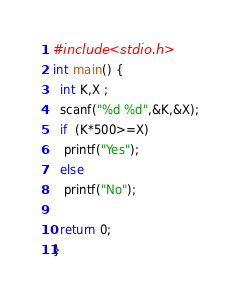<code> <loc_0><loc_0><loc_500><loc_500><_C_>#include <stdio.h>
int main() {
  int K,X ;
  scanf("%d %d",&K,&X);
  if  (K*500>=X)
   printf("Yes");
  else
   printf("No");

  return 0;
}</code> 